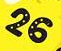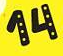Identify the words shown in these images in order, separated by a semicolon. 26; 14 